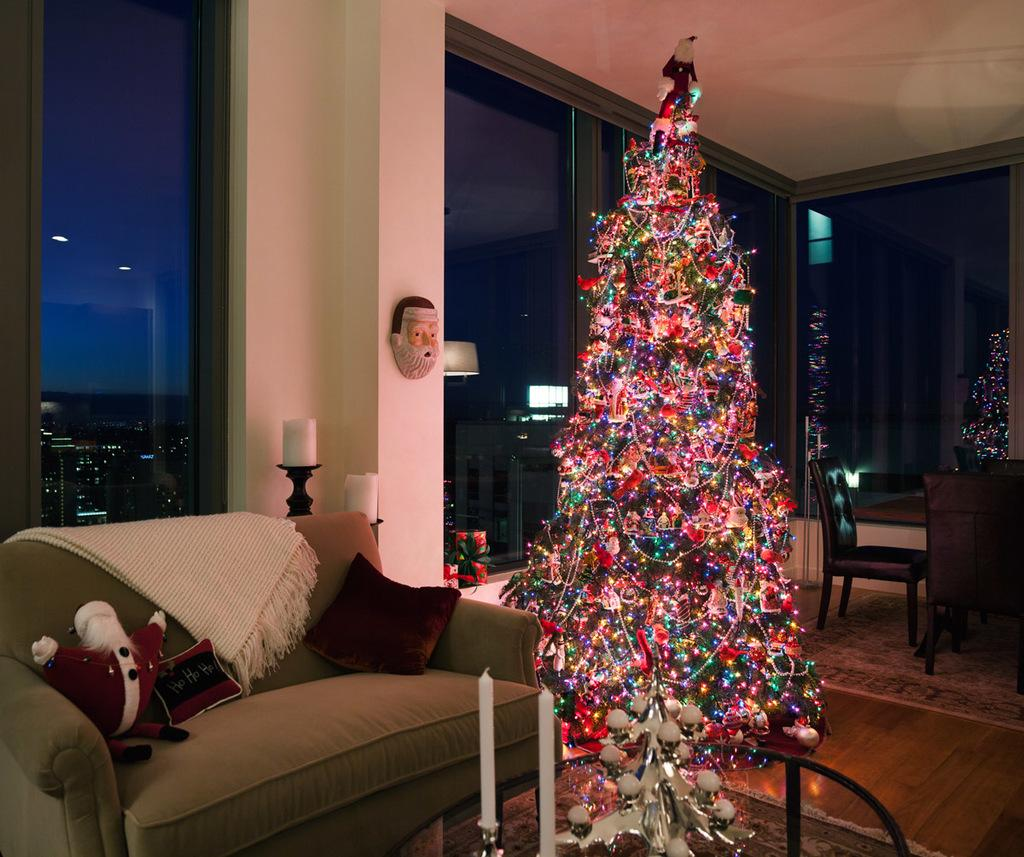What type of tree is in the image? There is a Christmas tree in the image. What are the two objects placed near the tree? There are two candles in the image. What piece of furniture is in the image? There is a couch in the image. What type of cushion is on the couch? There is a pillow in the image. What can be seen in the background of the image? There is a wall and a glass door in the background of the image. What type of sign can be seen on the coach in the image? There is no coach or sign present in the image. 